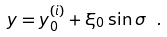<formula> <loc_0><loc_0><loc_500><loc_500>y = y _ { 0 } ^ { ( i ) } + \xi _ { 0 } \sin \sigma \ . \label l { e q \colon s o l u t i o n }</formula> 